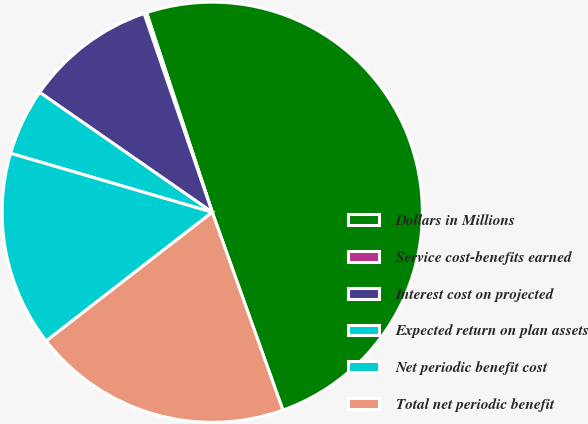<chart> <loc_0><loc_0><loc_500><loc_500><pie_chart><fcel>Dollars in Millions<fcel>Service cost-benefits earned<fcel>Interest cost on projected<fcel>Expected return on plan assets<fcel>Net periodic benefit cost<fcel>Total net periodic benefit<nl><fcel>49.6%<fcel>0.2%<fcel>10.08%<fcel>5.14%<fcel>15.02%<fcel>19.96%<nl></chart> 